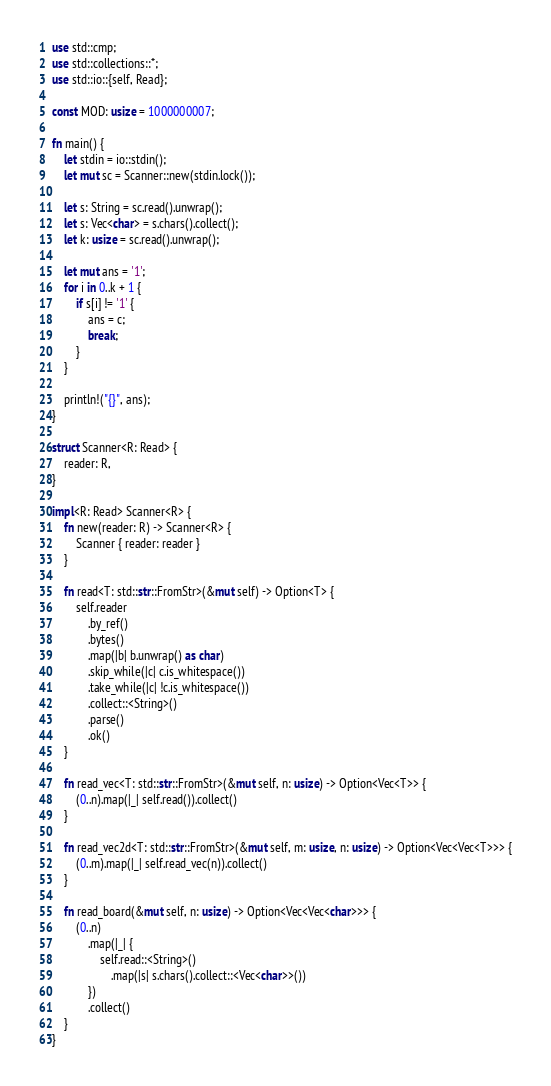Convert code to text. <code><loc_0><loc_0><loc_500><loc_500><_Rust_>use std::cmp;
use std::collections::*;
use std::io::{self, Read};

const MOD: usize = 1000000007;

fn main() {
    let stdin = io::stdin();
    let mut sc = Scanner::new(stdin.lock());

    let s: String = sc.read().unwrap();
    let s: Vec<char> = s.chars().collect();
    let k: usize = sc.read().unwrap();

    let mut ans = '1';
    for i in 0..k + 1 {
        if s[i] != '1' {
            ans = c;
            break;
        }
    }

    println!("{}", ans);
}

struct Scanner<R: Read> {
    reader: R,
}

impl<R: Read> Scanner<R> {
    fn new(reader: R) -> Scanner<R> {
        Scanner { reader: reader }
    }

    fn read<T: std::str::FromStr>(&mut self) -> Option<T> {
        self.reader
            .by_ref()
            .bytes()
            .map(|b| b.unwrap() as char)
            .skip_while(|c| c.is_whitespace())
            .take_while(|c| !c.is_whitespace())
            .collect::<String>()
            .parse()
            .ok()
    }

    fn read_vec<T: std::str::FromStr>(&mut self, n: usize) -> Option<Vec<T>> {
        (0..n).map(|_| self.read()).collect()
    }

    fn read_vec2d<T: std::str::FromStr>(&mut self, m: usize, n: usize) -> Option<Vec<Vec<T>>> {
        (0..m).map(|_| self.read_vec(n)).collect()
    }

    fn read_board(&mut self, n: usize) -> Option<Vec<Vec<char>>> {
        (0..n)
            .map(|_| {
                self.read::<String>()
                    .map(|s| s.chars().collect::<Vec<char>>())
            })
            .collect()
    }
}
</code> 